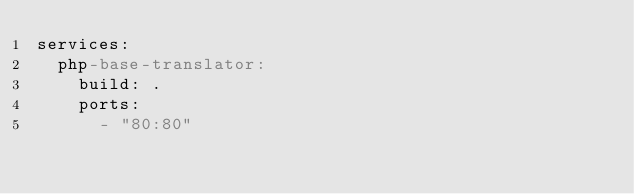Convert code to text. <code><loc_0><loc_0><loc_500><loc_500><_YAML_>services:
  php-base-translator:
    build: .
    ports:
      - "80:80"</code> 